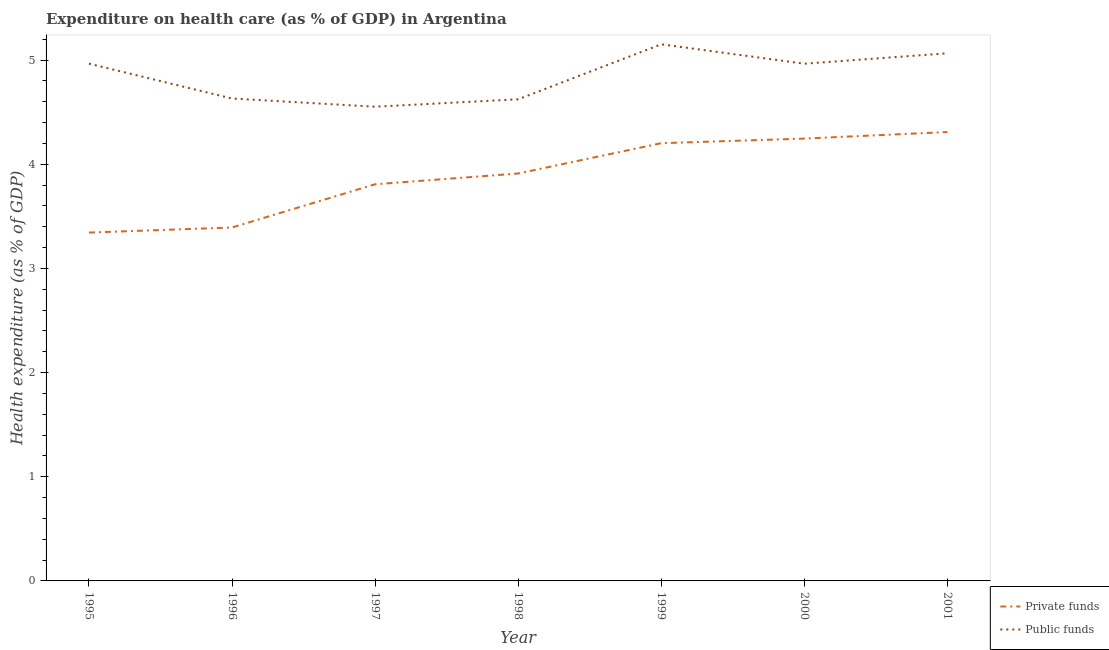How many different coloured lines are there?
Provide a short and direct response. 2. Is the number of lines equal to the number of legend labels?
Your response must be concise. Yes. What is the amount of private funds spent in healthcare in 1996?
Make the answer very short. 3.39. Across all years, what is the maximum amount of public funds spent in healthcare?
Provide a succinct answer. 5.15. Across all years, what is the minimum amount of public funds spent in healthcare?
Your answer should be very brief. 4.55. In which year was the amount of public funds spent in healthcare minimum?
Give a very brief answer. 1997. What is the total amount of private funds spent in healthcare in the graph?
Give a very brief answer. 27.22. What is the difference between the amount of public funds spent in healthcare in 1997 and that in 1999?
Give a very brief answer. -0.6. What is the difference between the amount of public funds spent in healthcare in 2000 and the amount of private funds spent in healthcare in 1996?
Your answer should be compact. 1.57. What is the average amount of private funds spent in healthcare per year?
Offer a terse response. 3.89. In the year 1998, what is the difference between the amount of private funds spent in healthcare and amount of public funds spent in healthcare?
Offer a terse response. -0.71. What is the ratio of the amount of private funds spent in healthcare in 1999 to that in 2000?
Your answer should be very brief. 0.99. What is the difference between the highest and the second highest amount of public funds spent in healthcare?
Your answer should be very brief. 0.09. What is the difference between the highest and the lowest amount of private funds spent in healthcare?
Your answer should be compact. 0.97. In how many years, is the amount of public funds spent in healthcare greater than the average amount of public funds spent in healthcare taken over all years?
Provide a short and direct response. 4. Is the sum of the amount of public funds spent in healthcare in 1998 and 2000 greater than the maximum amount of private funds spent in healthcare across all years?
Your answer should be compact. Yes. Does the amount of public funds spent in healthcare monotonically increase over the years?
Keep it short and to the point. No. How many lines are there?
Give a very brief answer. 2. What is the difference between two consecutive major ticks on the Y-axis?
Keep it short and to the point. 1. Are the values on the major ticks of Y-axis written in scientific E-notation?
Your answer should be compact. No. Does the graph contain grids?
Your response must be concise. No. Where does the legend appear in the graph?
Offer a terse response. Bottom right. What is the title of the graph?
Your answer should be compact. Expenditure on health care (as % of GDP) in Argentina. Does "Fraud firms" appear as one of the legend labels in the graph?
Give a very brief answer. No. What is the label or title of the X-axis?
Your response must be concise. Year. What is the label or title of the Y-axis?
Provide a short and direct response. Health expenditure (as % of GDP). What is the Health expenditure (as % of GDP) in Private funds in 1995?
Offer a terse response. 3.34. What is the Health expenditure (as % of GDP) in Public funds in 1995?
Your answer should be very brief. 4.97. What is the Health expenditure (as % of GDP) in Private funds in 1996?
Give a very brief answer. 3.39. What is the Health expenditure (as % of GDP) of Public funds in 1996?
Provide a short and direct response. 4.63. What is the Health expenditure (as % of GDP) of Private funds in 1997?
Your response must be concise. 3.81. What is the Health expenditure (as % of GDP) in Public funds in 1997?
Your answer should be compact. 4.55. What is the Health expenditure (as % of GDP) of Private funds in 1998?
Provide a succinct answer. 3.91. What is the Health expenditure (as % of GDP) of Public funds in 1998?
Offer a very short reply. 4.62. What is the Health expenditure (as % of GDP) in Private funds in 1999?
Give a very brief answer. 4.2. What is the Health expenditure (as % of GDP) of Public funds in 1999?
Make the answer very short. 5.15. What is the Health expenditure (as % of GDP) of Private funds in 2000?
Keep it short and to the point. 4.25. What is the Health expenditure (as % of GDP) in Public funds in 2000?
Ensure brevity in your answer.  4.97. What is the Health expenditure (as % of GDP) in Private funds in 2001?
Offer a very short reply. 4.31. What is the Health expenditure (as % of GDP) in Public funds in 2001?
Offer a terse response. 5.07. Across all years, what is the maximum Health expenditure (as % of GDP) in Private funds?
Provide a succinct answer. 4.31. Across all years, what is the maximum Health expenditure (as % of GDP) in Public funds?
Provide a short and direct response. 5.15. Across all years, what is the minimum Health expenditure (as % of GDP) in Private funds?
Offer a terse response. 3.34. Across all years, what is the minimum Health expenditure (as % of GDP) in Public funds?
Keep it short and to the point. 4.55. What is the total Health expenditure (as % of GDP) in Private funds in the graph?
Provide a short and direct response. 27.22. What is the total Health expenditure (as % of GDP) of Public funds in the graph?
Offer a very short reply. 33.96. What is the difference between the Health expenditure (as % of GDP) of Private funds in 1995 and that in 1996?
Provide a succinct answer. -0.05. What is the difference between the Health expenditure (as % of GDP) of Public funds in 1995 and that in 1996?
Offer a terse response. 0.33. What is the difference between the Health expenditure (as % of GDP) in Private funds in 1995 and that in 1997?
Keep it short and to the point. -0.46. What is the difference between the Health expenditure (as % of GDP) in Public funds in 1995 and that in 1997?
Provide a short and direct response. 0.41. What is the difference between the Health expenditure (as % of GDP) in Private funds in 1995 and that in 1998?
Offer a terse response. -0.57. What is the difference between the Health expenditure (as % of GDP) in Public funds in 1995 and that in 1998?
Ensure brevity in your answer.  0.34. What is the difference between the Health expenditure (as % of GDP) in Private funds in 1995 and that in 1999?
Your answer should be compact. -0.86. What is the difference between the Health expenditure (as % of GDP) of Public funds in 1995 and that in 1999?
Offer a terse response. -0.19. What is the difference between the Health expenditure (as % of GDP) in Private funds in 1995 and that in 2000?
Give a very brief answer. -0.9. What is the difference between the Health expenditure (as % of GDP) of Public funds in 1995 and that in 2000?
Keep it short and to the point. 0. What is the difference between the Health expenditure (as % of GDP) of Private funds in 1995 and that in 2001?
Provide a short and direct response. -0.97. What is the difference between the Health expenditure (as % of GDP) in Public funds in 1995 and that in 2001?
Provide a succinct answer. -0.1. What is the difference between the Health expenditure (as % of GDP) of Private funds in 1996 and that in 1997?
Provide a succinct answer. -0.41. What is the difference between the Health expenditure (as % of GDP) of Public funds in 1996 and that in 1997?
Provide a short and direct response. 0.08. What is the difference between the Health expenditure (as % of GDP) of Private funds in 1996 and that in 1998?
Your response must be concise. -0.52. What is the difference between the Health expenditure (as % of GDP) of Public funds in 1996 and that in 1998?
Make the answer very short. 0.01. What is the difference between the Health expenditure (as % of GDP) in Private funds in 1996 and that in 1999?
Offer a terse response. -0.81. What is the difference between the Health expenditure (as % of GDP) in Public funds in 1996 and that in 1999?
Offer a very short reply. -0.52. What is the difference between the Health expenditure (as % of GDP) in Private funds in 1996 and that in 2000?
Your answer should be compact. -0.85. What is the difference between the Health expenditure (as % of GDP) of Public funds in 1996 and that in 2000?
Keep it short and to the point. -0.33. What is the difference between the Health expenditure (as % of GDP) of Private funds in 1996 and that in 2001?
Your answer should be very brief. -0.92. What is the difference between the Health expenditure (as % of GDP) in Public funds in 1996 and that in 2001?
Keep it short and to the point. -0.43. What is the difference between the Health expenditure (as % of GDP) in Private funds in 1997 and that in 1998?
Make the answer very short. -0.1. What is the difference between the Health expenditure (as % of GDP) of Public funds in 1997 and that in 1998?
Give a very brief answer. -0.07. What is the difference between the Health expenditure (as % of GDP) of Private funds in 1997 and that in 1999?
Your answer should be very brief. -0.39. What is the difference between the Health expenditure (as % of GDP) in Public funds in 1997 and that in 1999?
Ensure brevity in your answer.  -0.6. What is the difference between the Health expenditure (as % of GDP) in Private funds in 1997 and that in 2000?
Your response must be concise. -0.44. What is the difference between the Health expenditure (as % of GDP) of Public funds in 1997 and that in 2000?
Provide a short and direct response. -0.41. What is the difference between the Health expenditure (as % of GDP) of Private funds in 1997 and that in 2001?
Offer a terse response. -0.5. What is the difference between the Health expenditure (as % of GDP) in Public funds in 1997 and that in 2001?
Provide a short and direct response. -0.51. What is the difference between the Health expenditure (as % of GDP) in Private funds in 1998 and that in 1999?
Your answer should be compact. -0.29. What is the difference between the Health expenditure (as % of GDP) of Public funds in 1998 and that in 1999?
Offer a very short reply. -0.53. What is the difference between the Health expenditure (as % of GDP) of Private funds in 1998 and that in 2000?
Your answer should be very brief. -0.34. What is the difference between the Health expenditure (as % of GDP) in Public funds in 1998 and that in 2000?
Offer a terse response. -0.34. What is the difference between the Health expenditure (as % of GDP) in Private funds in 1998 and that in 2001?
Provide a succinct answer. -0.4. What is the difference between the Health expenditure (as % of GDP) of Public funds in 1998 and that in 2001?
Keep it short and to the point. -0.44. What is the difference between the Health expenditure (as % of GDP) of Private funds in 1999 and that in 2000?
Your response must be concise. -0.04. What is the difference between the Health expenditure (as % of GDP) in Public funds in 1999 and that in 2000?
Keep it short and to the point. 0.19. What is the difference between the Health expenditure (as % of GDP) in Private funds in 1999 and that in 2001?
Offer a terse response. -0.11. What is the difference between the Health expenditure (as % of GDP) in Public funds in 1999 and that in 2001?
Keep it short and to the point. 0.09. What is the difference between the Health expenditure (as % of GDP) of Private funds in 2000 and that in 2001?
Your answer should be compact. -0.06. What is the difference between the Health expenditure (as % of GDP) of Public funds in 2000 and that in 2001?
Keep it short and to the point. -0.1. What is the difference between the Health expenditure (as % of GDP) of Private funds in 1995 and the Health expenditure (as % of GDP) of Public funds in 1996?
Offer a very short reply. -1.29. What is the difference between the Health expenditure (as % of GDP) of Private funds in 1995 and the Health expenditure (as % of GDP) of Public funds in 1997?
Your answer should be very brief. -1.21. What is the difference between the Health expenditure (as % of GDP) in Private funds in 1995 and the Health expenditure (as % of GDP) in Public funds in 1998?
Your response must be concise. -1.28. What is the difference between the Health expenditure (as % of GDP) of Private funds in 1995 and the Health expenditure (as % of GDP) of Public funds in 1999?
Your response must be concise. -1.81. What is the difference between the Health expenditure (as % of GDP) of Private funds in 1995 and the Health expenditure (as % of GDP) of Public funds in 2000?
Your answer should be very brief. -1.62. What is the difference between the Health expenditure (as % of GDP) of Private funds in 1995 and the Health expenditure (as % of GDP) of Public funds in 2001?
Offer a very short reply. -1.72. What is the difference between the Health expenditure (as % of GDP) in Private funds in 1996 and the Health expenditure (as % of GDP) in Public funds in 1997?
Keep it short and to the point. -1.16. What is the difference between the Health expenditure (as % of GDP) of Private funds in 1996 and the Health expenditure (as % of GDP) of Public funds in 1998?
Give a very brief answer. -1.23. What is the difference between the Health expenditure (as % of GDP) of Private funds in 1996 and the Health expenditure (as % of GDP) of Public funds in 1999?
Give a very brief answer. -1.76. What is the difference between the Health expenditure (as % of GDP) of Private funds in 1996 and the Health expenditure (as % of GDP) of Public funds in 2000?
Offer a very short reply. -1.57. What is the difference between the Health expenditure (as % of GDP) of Private funds in 1996 and the Health expenditure (as % of GDP) of Public funds in 2001?
Your response must be concise. -1.67. What is the difference between the Health expenditure (as % of GDP) of Private funds in 1997 and the Health expenditure (as % of GDP) of Public funds in 1998?
Your response must be concise. -0.82. What is the difference between the Health expenditure (as % of GDP) in Private funds in 1997 and the Health expenditure (as % of GDP) in Public funds in 1999?
Provide a succinct answer. -1.34. What is the difference between the Health expenditure (as % of GDP) in Private funds in 1997 and the Health expenditure (as % of GDP) in Public funds in 2000?
Provide a succinct answer. -1.16. What is the difference between the Health expenditure (as % of GDP) of Private funds in 1997 and the Health expenditure (as % of GDP) of Public funds in 2001?
Your response must be concise. -1.26. What is the difference between the Health expenditure (as % of GDP) in Private funds in 1998 and the Health expenditure (as % of GDP) in Public funds in 1999?
Provide a succinct answer. -1.24. What is the difference between the Health expenditure (as % of GDP) in Private funds in 1998 and the Health expenditure (as % of GDP) in Public funds in 2000?
Keep it short and to the point. -1.05. What is the difference between the Health expenditure (as % of GDP) in Private funds in 1998 and the Health expenditure (as % of GDP) in Public funds in 2001?
Your answer should be compact. -1.15. What is the difference between the Health expenditure (as % of GDP) in Private funds in 1999 and the Health expenditure (as % of GDP) in Public funds in 2000?
Your answer should be very brief. -0.76. What is the difference between the Health expenditure (as % of GDP) of Private funds in 1999 and the Health expenditure (as % of GDP) of Public funds in 2001?
Provide a succinct answer. -0.86. What is the difference between the Health expenditure (as % of GDP) of Private funds in 2000 and the Health expenditure (as % of GDP) of Public funds in 2001?
Provide a short and direct response. -0.82. What is the average Health expenditure (as % of GDP) of Private funds per year?
Offer a terse response. 3.89. What is the average Health expenditure (as % of GDP) in Public funds per year?
Provide a succinct answer. 4.85. In the year 1995, what is the difference between the Health expenditure (as % of GDP) in Private funds and Health expenditure (as % of GDP) in Public funds?
Offer a very short reply. -1.62. In the year 1996, what is the difference between the Health expenditure (as % of GDP) of Private funds and Health expenditure (as % of GDP) of Public funds?
Ensure brevity in your answer.  -1.24. In the year 1997, what is the difference between the Health expenditure (as % of GDP) in Private funds and Health expenditure (as % of GDP) in Public funds?
Your response must be concise. -0.74. In the year 1998, what is the difference between the Health expenditure (as % of GDP) of Private funds and Health expenditure (as % of GDP) of Public funds?
Make the answer very short. -0.71. In the year 1999, what is the difference between the Health expenditure (as % of GDP) of Private funds and Health expenditure (as % of GDP) of Public funds?
Your answer should be compact. -0.95. In the year 2000, what is the difference between the Health expenditure (as % of GDP) of Private funds and Health expenditure (as % of GDP) of Public funds?
Offer a terse response. -0.72. In the year 2001, what is the difference between the Health expenditure (as % of GDP) in Private funds and Health expenditure (as % of GDP) in Public funds?
Offer a terse response. -0.76. What is the ratio of the Health expenditure (as % of GDP) in Private funds in 1995 to that in 1996?
Give a very brief answer. 0.99. What is the ratio of the Health expenditure (as % of GDP) of Public funds in 1995 to that in 1996?
Offer a terse response. 1.07. What is the ratio of the Health expenditure (as % of GDP) of Private funds in 1995 to that in 1997?
Ensure brevity in your answer.  0.88. What is the ratio of the Health expenditure (as % of GDP) in Public funds in 1995 to that in 1997?
Your answer should be compact. 1.09. What is the ratio of the Health expenditure (as % of GDP) of Private funds in 1995 to that in 1998?
Offer a terse response. 0.85. What is the ratio of the Health expenditure (as % of GDP) in Public funds in 1995 to that in 1998?
Keep it short and to the point. 1.07. What is the ratio of the Health expenditure (as % of GDP) in Private funds in 1995 to that in 1999?
Your response must be concise. 0.8. What is the ratio of the Health expenditure (as % of GDP) in Public funds in 1995 to that in 1999?
Your answer should be very brief. 0.96. What is the ratio of the Health expenditure (as % of GDP) of Private funds in 1995 to that in 2000?
Ensure brevity in your answer.  0.79. What is the ratio of the Health expenditure (as % of GDP) of Private funds in 1995 to that in 2001?
Provide a succinct answer. 0.78. What is the ratio of the Health expenditure (as % of GDP) of Public funds in 1995 to that in 2001?
Keep it short and to the point. 0.98. What is the ratio of the Health expenditure (as % of GDP) in Private funds in 1996 to that in 1997?
Make the answer very short. 0.89. What is the ratio of the Health expenditure (as % of GDP) of Public funds in 1996 to that in 1997?
Your response must be concise. 1.02. What is the ratio of the Health expenditure (as % of GDP) of Private funds in 1996 to that in 1998?
Ensure brevity in your answer.  0.87. What is the ratio of the Health expenditure (as % of GDP) in Public funds in 1996 to that in 1998?
Give a very brief answer. 1. What is the ratio of the Health expenditure (as % of GDP) in Private funds in 1996 to that in 1999?
Give a very brief answer. 0.81. What is the ratio of the Health expenditure (as % of GDP) in Public funds in 1996 to that in 1999?
Your response must be concise. 0.9. What is the ratio of the Health expenditure (as % of GDP) in Private funds in 1996 to that in 2000?
Your response must be concise. 0.8. What is the ratio of the Health expenditure (as % of GDP) of Public funds in 1996 to that in 2000?
Keep it short and to the point. 0.93. What is the ratio of the Health expenditure (as % of GDP) of Private funds in 1996 to that in 2001?
Keep it short and to the point. 0.79. What is the ratio of the Health expenditure (as % of GDP) in Public funds in 1996 to that in 2001?
Your answer should be compact. 0.91. What is the ratio of the Health expenditure (as % of GDP) of Private funds in 1997 to that in 1998?
Keep it short and to the point. 0.97. What is the ratio of the Health expenditure (as % of GDP) of Public funds in 1997 to that in 1998?
Offer a terse response. 0.98. What is the ratio of the Health expenditure (as % of GDP) in Private funds in 1997 to that in 1999?
Offer a terse response. 0.91. What is the ratio of the Health expenditure (as % of GDP) of Public funds in 1997 to that in 1999?
Make the answer very short. 0.88. What is the ratio of the Health expenditure (as % of GDP) of Private funds in 1997 to that in 2000?
Provide a short and direct response. 0.9. What is the ratio of the Health expenditure (as % of GDP) in Public funds in 1997 to that in 2000?
Give a very brief answer. 0.92. What is the ratio of the Health expenditure (as % of GDP) in Private funds in 1997 to that in 2001?
Offer a very short reply. 0.88. What is the ratio of the Health expenditure (as % of GDP) in Public funds in 1997 to that in 2001?
Your answer should be very brief. 0.9. What is the ratio of the Health expenditure (as % of GDP) of Private funds in 1998 to that in 1999?
Offer a terse response. 0.93. What is the ratio of the Health expenditure (as % of GDP) of Public funds in 1998 to that in 1999?
Offer a very short reply. 0.9. What is the ratio of the Health expenditure (as % of GDP) in Private funds in 1998 to that in 2000?
Make the answer very short. 0.92. What is the ratio of the Health expenditure (as % of GDP) in Public funds in 1998 to that in 2000?
Ensure brevity in your answer.  0.93. What is the ratio of the Health expenditure (as % of GDP) in Private funds in 1998 to that in 2001?
Your answer should be very brief. 0.91. What is the ratio of the Health expenditure (as % of GDP) in Public funds in 1998 to that in 2001?
Your answer should be compact. 0.91. What is the ratio of the Health expenditure (as % of GDP) of Private funds in 1999 to that in 2000?
Offer a very short reply. 0.99. What is the ratio of the Health expenditure (as % of GDP) in Public funds in 1999 to that in 2000?
Your answer should be compact. 1.04. What is the ratio of the Health expenditure (as % of GDP) in Private funds in 1999 to that in 2001?
Make the answer very short. 0.98. What is the ratio of the Health expenditure (as % of GDP) of Public funds in 1999 to that in 2001?
Your response must be concise. 1.02. What is the ratio of the Health expenditure (as % of GDP) of Private funds in 2000 to that in 2001?
Keep it short and to the point. 0.99. What is the ratio of the Health expenditure (as % of GDP) of Public funds in 2000 to that in 2001?
Ensure brevity in your answer.  0.98. What is the difference between the highest and the second highest Health expenditure (as % of GDP) of Private funds?
Keep it short and to the point. 0.06. What is the difference between the highest and the second highest Health expenditure (as % of GDP) in Public funds?
Ensure brevity in your answer.  0.09. What is the difference between the highest and the lowest Health expenditure (as % of GDP) of Private funds?
Offer a very short reply. 0.97. What is the difference between the highest and the lowest Health expenditure (as % of GDP) of Public funds?
Your answer should be compact. 0.6. 